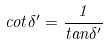<formula> <loc_0><loc_0><loc_500><loc_500>c o t \delta ^ { \prime } = \frac { 1 } { t a n \delta ^ { \prime } }</formula> 